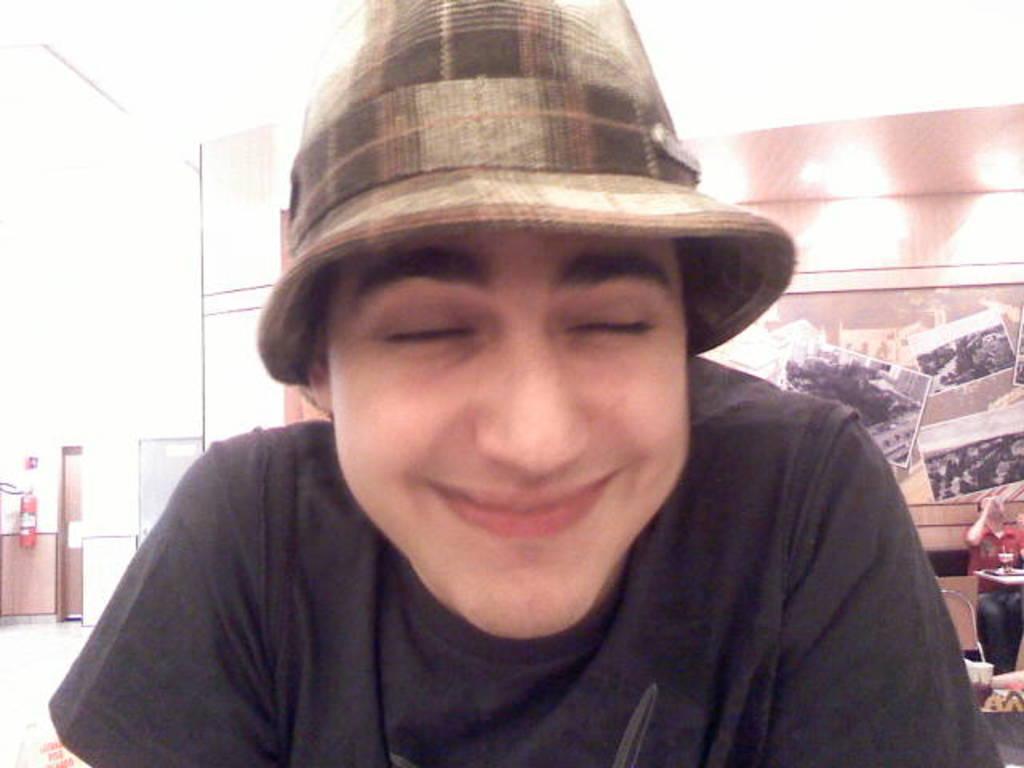Can you describe this image briefly? In the center of the image, we can see a person wearing a hat and in the background, there are some posters on the wall and we can see an other person sitting and we can see chairs and some other objects on the tables and there is a refrigerator and a fire extinguisher and an object on the wall. 